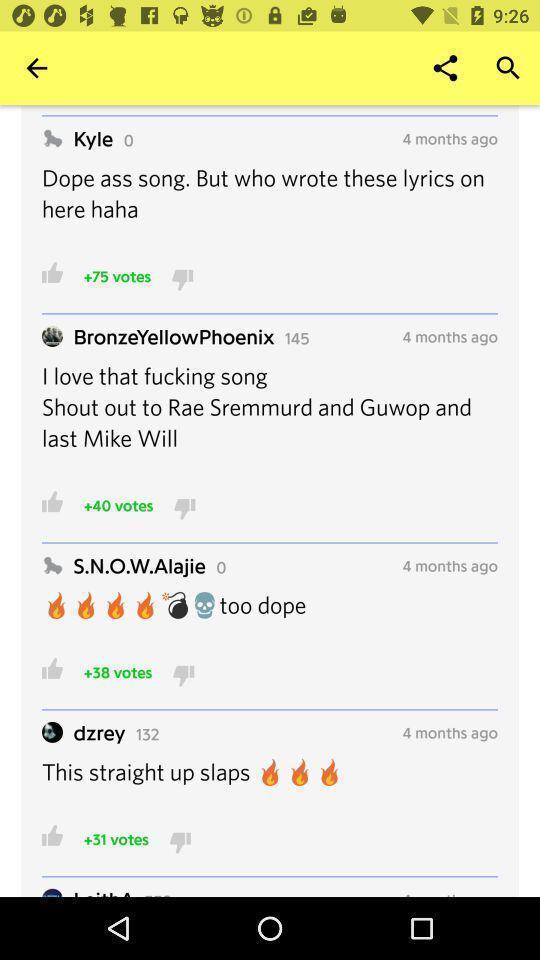What details can you identify in this image? Page shows some text in an music application. 